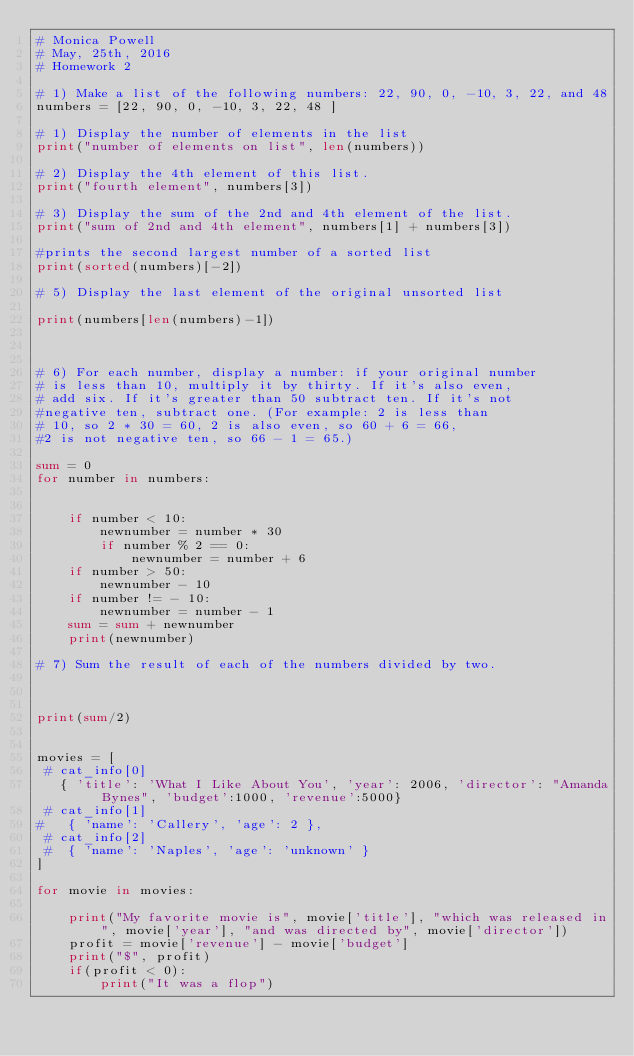<code> <loc_0><loc_0><loc_500><loc_500><_Python_># Monica Powell
# May, 25th, 2016
# Homework 2

# 1) Make a list of the following numbers: 22, 90, 0, -10, 3, 22, and 48
numbers = [22, 90, 0, -10, 3, 22, 48 ]

# 1) Display the number of elements in the list
print("number of elements on list", len(numbers))

# 2) Display the 4th element of this list.
print("fourth element", numbers[3])

# 3) Display the sum of the 2nd and 4th element of the list.
print("sum of 2nd and 4th element", numbers[1] + numbers[3])

#prints the second largest number of a sorted list
print(sorted(numbers)[-2])

# 5) Display the last element of the original unsorted list

print(numbers[len(numbers)-1])



# 6) For each number, display a number: if your original number
# is less than 10, multiply it by thirty. If it's also even,
# add six. If it's greater than 50 subtract ten. If it's not
#negative ten, subtract one. (For example: 2 is less than
# 10, so 2 * 30 = 60, 2 is also even, so 60 + 6 = 66,
#2 is not negative ten, so 66 - 1 = 65.)

sum = 0
for number in numbers:


    if number < 10:
        newnumber = number * 30
        if number % 2 == 0:
            newnumber = number + 6
    if number > 50:
        newnumber - 10
    if number != - 10:
        newnumber = number - 1
    sum = sum + newnumber
    print(newnumber)

# 7) Sum the result of each of the numbers divided by two.



print(sum/2)


movies = [
 # cat_info[0]
   { 'title': 'What I Like About You', 'year': 2006, 'director': "Amanda Bynes", 'budget':1000, 'revenue':5000}
 # cat_info[1]
#   { 'name': 'Callery', 'age': 2 },
 # cat_info[2]
 #  { 'name': 'Naples', 'age': 'unknown' }
]

for movie in movies:

    print("My favorite movie is", movie['title'], "which was released in", movie['year'], "and was directed by", movie['director'])
    profit = movie['revenue'] - movie['budget']
    print("$", profit)
    if(profit < 0):
        print("It was a flop")</code> 